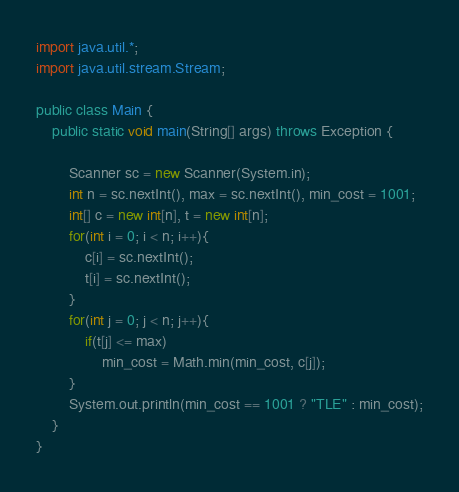<code> <loc_0><loc_0><loc_500><loc_500><_Java_>import java.util.*;
import java.util.stream.Stream;

public class Main {
    public static void main(String[] args) throws Exception {
        
        Scanner sc = new Scanner(System.in);
        int n = sc.nextInt(), max = sc.nextInt(), min_cost = 1001;
        int[] c = new int[n], t = new int[n];
        for(int i = 0; i < n; i++){
            c[i] = sc.nextInt();
            t[i] = sc.nextInt();
        }
        for(int j = 0; j < n; j++){
        	if(t[j] <= max)
        		min_cost = Math.min(min_cost, c[j]);
        }
        System.out.println(min_cost == 1001 ? "TLE" : min_cost);
    }
}</code> 